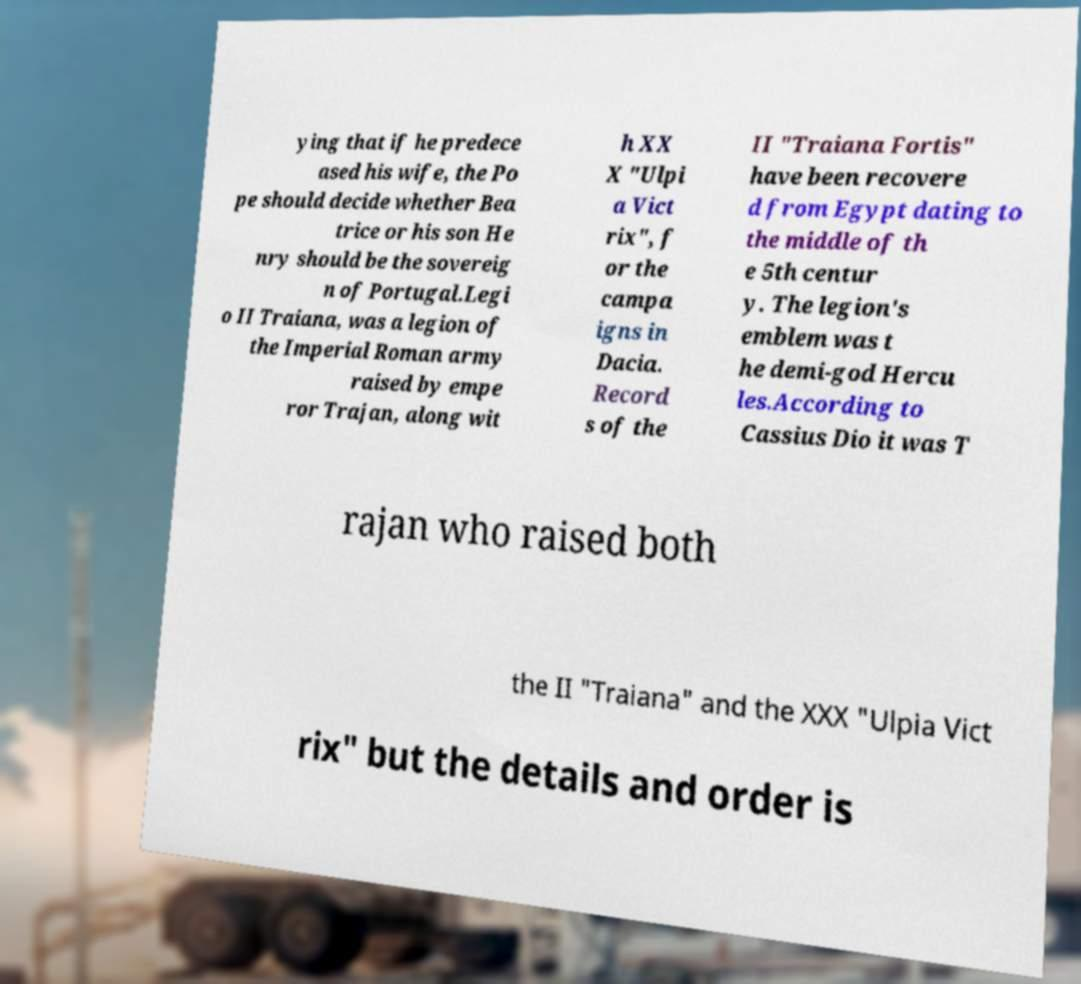Could you assist in decoding the text presented in this image and type it out clearly? ying that if he predece ased his wife, the Po pe should decide whether Bea trice or his son He nry should be the sovereig n of Portugal.Legi o II Traiana, was a legion of the Imperial Roman army raised by empe ror Trajan, along wit h XX X "Ulpi a Vict rix", f or the campa igns in Dacia. Record s of the II "Traiana Fortis" have been recovere d from Egypt dating to the middle of th e 5th centur y. The legion's emblem was t he demi-god Hercu les.According to Cassius Dio it was T rajan who raised both the II "Traiana" and the XXX "Ulpia Vict rix" but the details and order is 